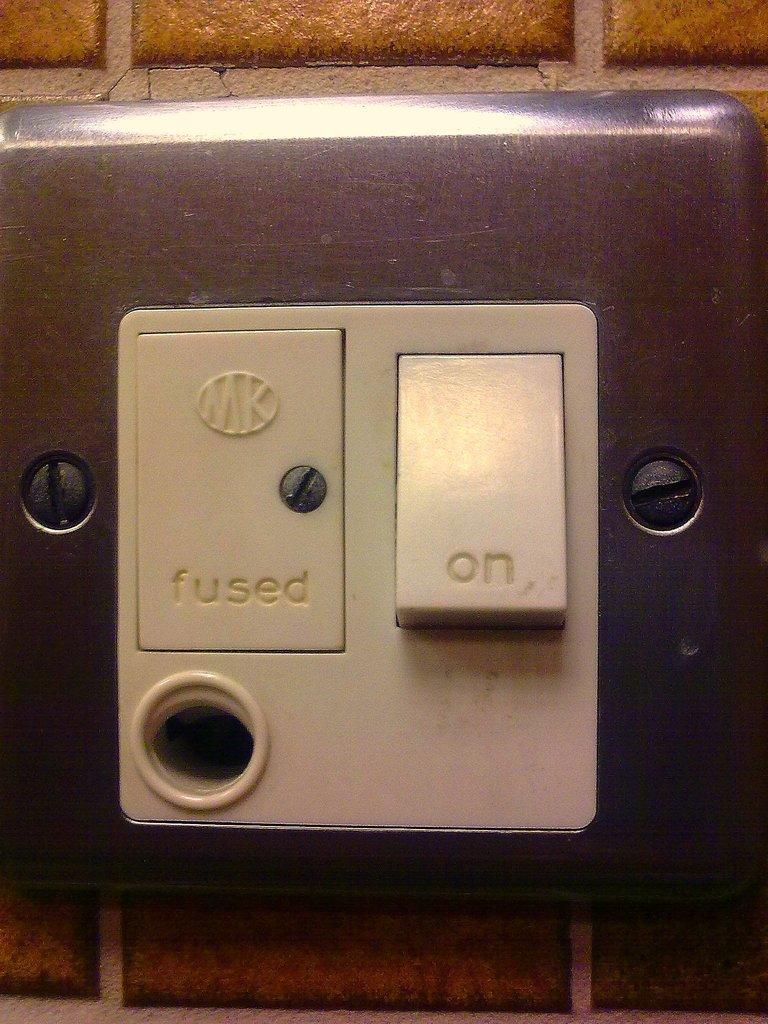<image>
Provide a brief description of the given image. A switch where the On switch is turned on 